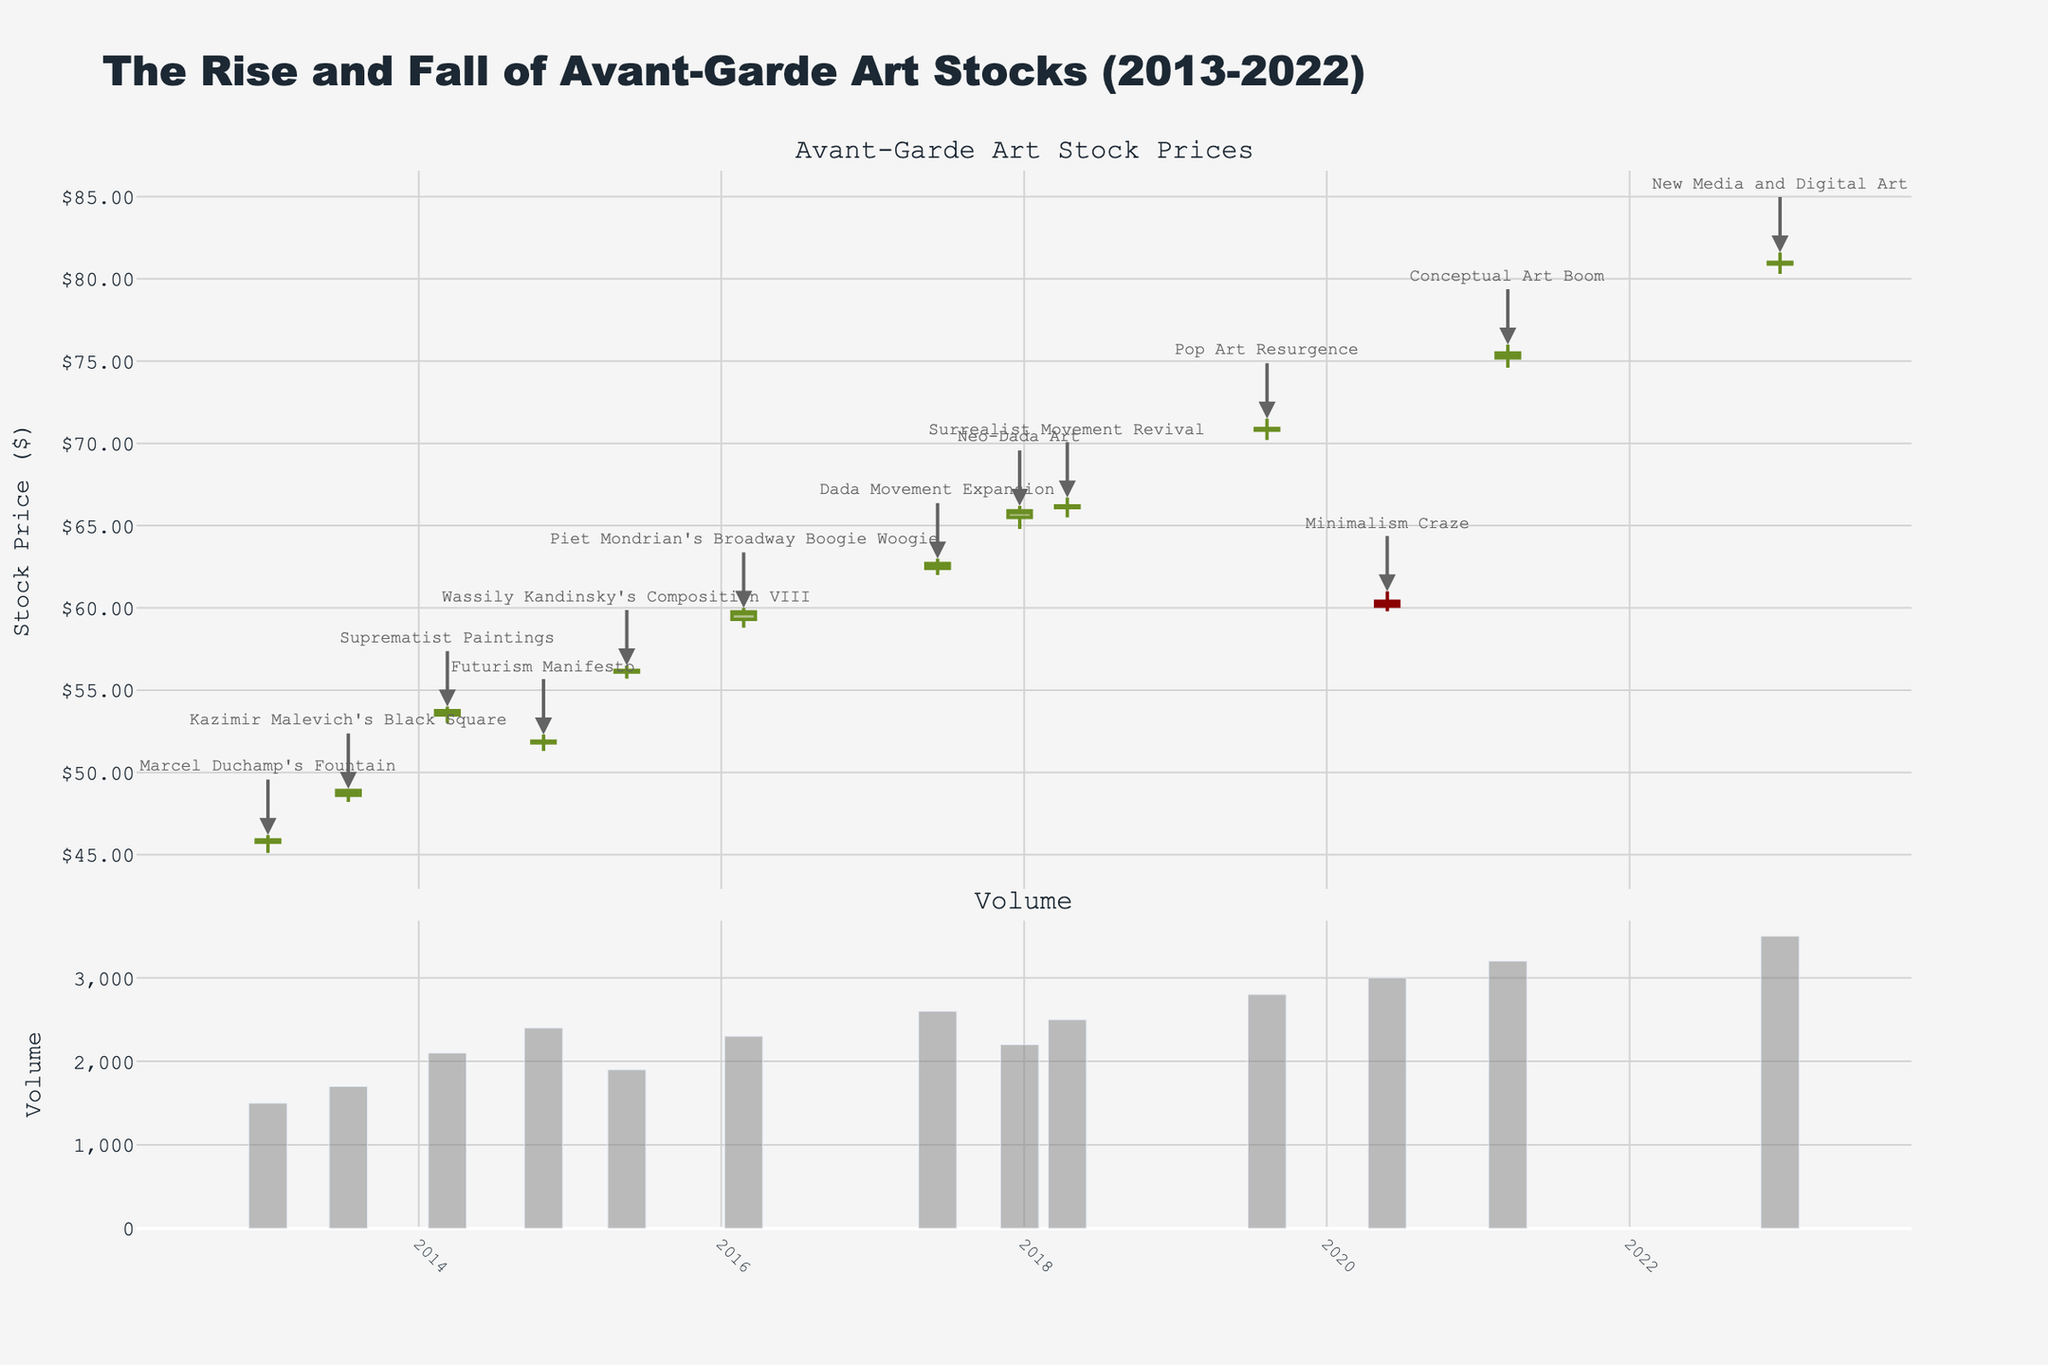What is the title of the plot? The title is prominently displayed at the top of the chart, indicating the overall theme of the data being visualized.
Answer: The Rise and Fall of Avant-Garde Art Stocks (2013-2022) How many candlestick data points are there in the figure? Count each unique candlestick, representing an individual date, visible in the upper part of the plot.
Answer: 12 What is the highest stock price recorded, and when did this occur? Identify the candlestick with the highest "High" value and check the corresponding date below it. The annotation might help if it overlaps with the highest point.
Answer: $81.60 on 2022-12-30 What are the open and close prices for Marcel Duchamp's Fountain in 2013? Locate the annotation for Marcel Duchamp's Fountain, then refer to the candlestick corresponding to this date. Check the 'Open' and 'Close' values from the graphical representation.
Answer: 45.75 (Open), 45.90 (Close) Between which two dates did the largest increase in closing price occur? Analyze the 'Close' prices and look for the largest positive difference by comparing consecutive candlesticks.
Answer: 2020-05-26 to 2021-03-13 Considering the Suprematist Paintings and Futurism Manifesto events, by how many points did the closing stock decrease? Locate the dates for the Suprematist Paintings and Futurism Manifesto, then find the 'Close' values for these dates. Calculate the difference (decrease).
Answer: 1.85 points (53.75 - 51.90) Which artistic movement had the highest trading volume, and what was that volume? Navigate to the lower part of the plot displaying the volumes and identify the highest bar. Check the annotation for the corresponding date and volume.
Answer: New Media and Digital Art (3500) What is the overall trend of the avant-garde art stock prices from 2013 to 2022? Observe the starting and ending points of the candlestick plot, along with any notable peaks and valleys. Determine the general direction (increasing, decreasing, stable) over the 10-year period.
Answer: Increasing What cultural trend corresponds to a significant drop in stock price in recent years? Locate any notable drops in the candlestick chart, particularly if accompanied by a volume spike that might indicate a significant market reaction. Check for annotations around those dates.
Answer: Minimalism Craze Between which two periods did the average volume trading significantly increase? Examine the volume bars across different time intervals for noticeable increases. Calculate average volumes before and after a potential breakpoint.
Answer: 2019-2020 vs. 2021-2022 